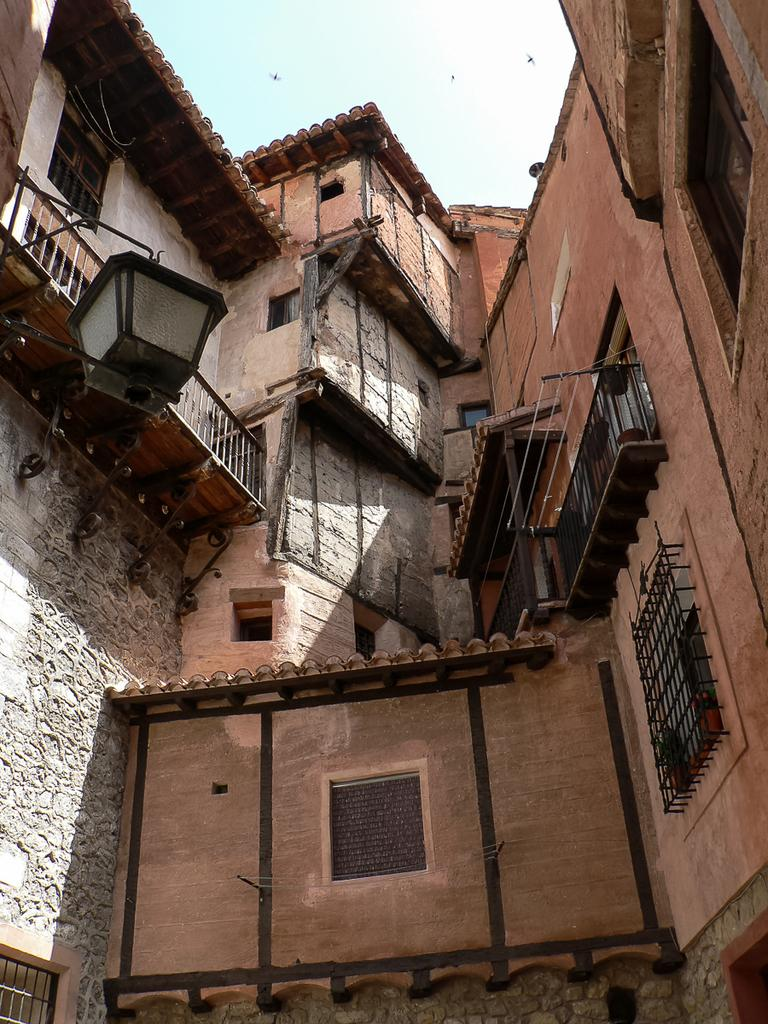What type of structure is present in the image? There is a building in the image. What architectural feature can be seen on the building? There are grilles in the image. Where is the light located in the image? The light is on the left side of the image. What can be seen in the distance in the image? The sky is visible in the background of the image. What type of quill is being used to write on the building in the image? There is no quill or writing present on the building in the image. Is there any sleet visible in the image? There is no mention of sleet or any weather conditions in the provided facts, so it cannot be determined from the image. 